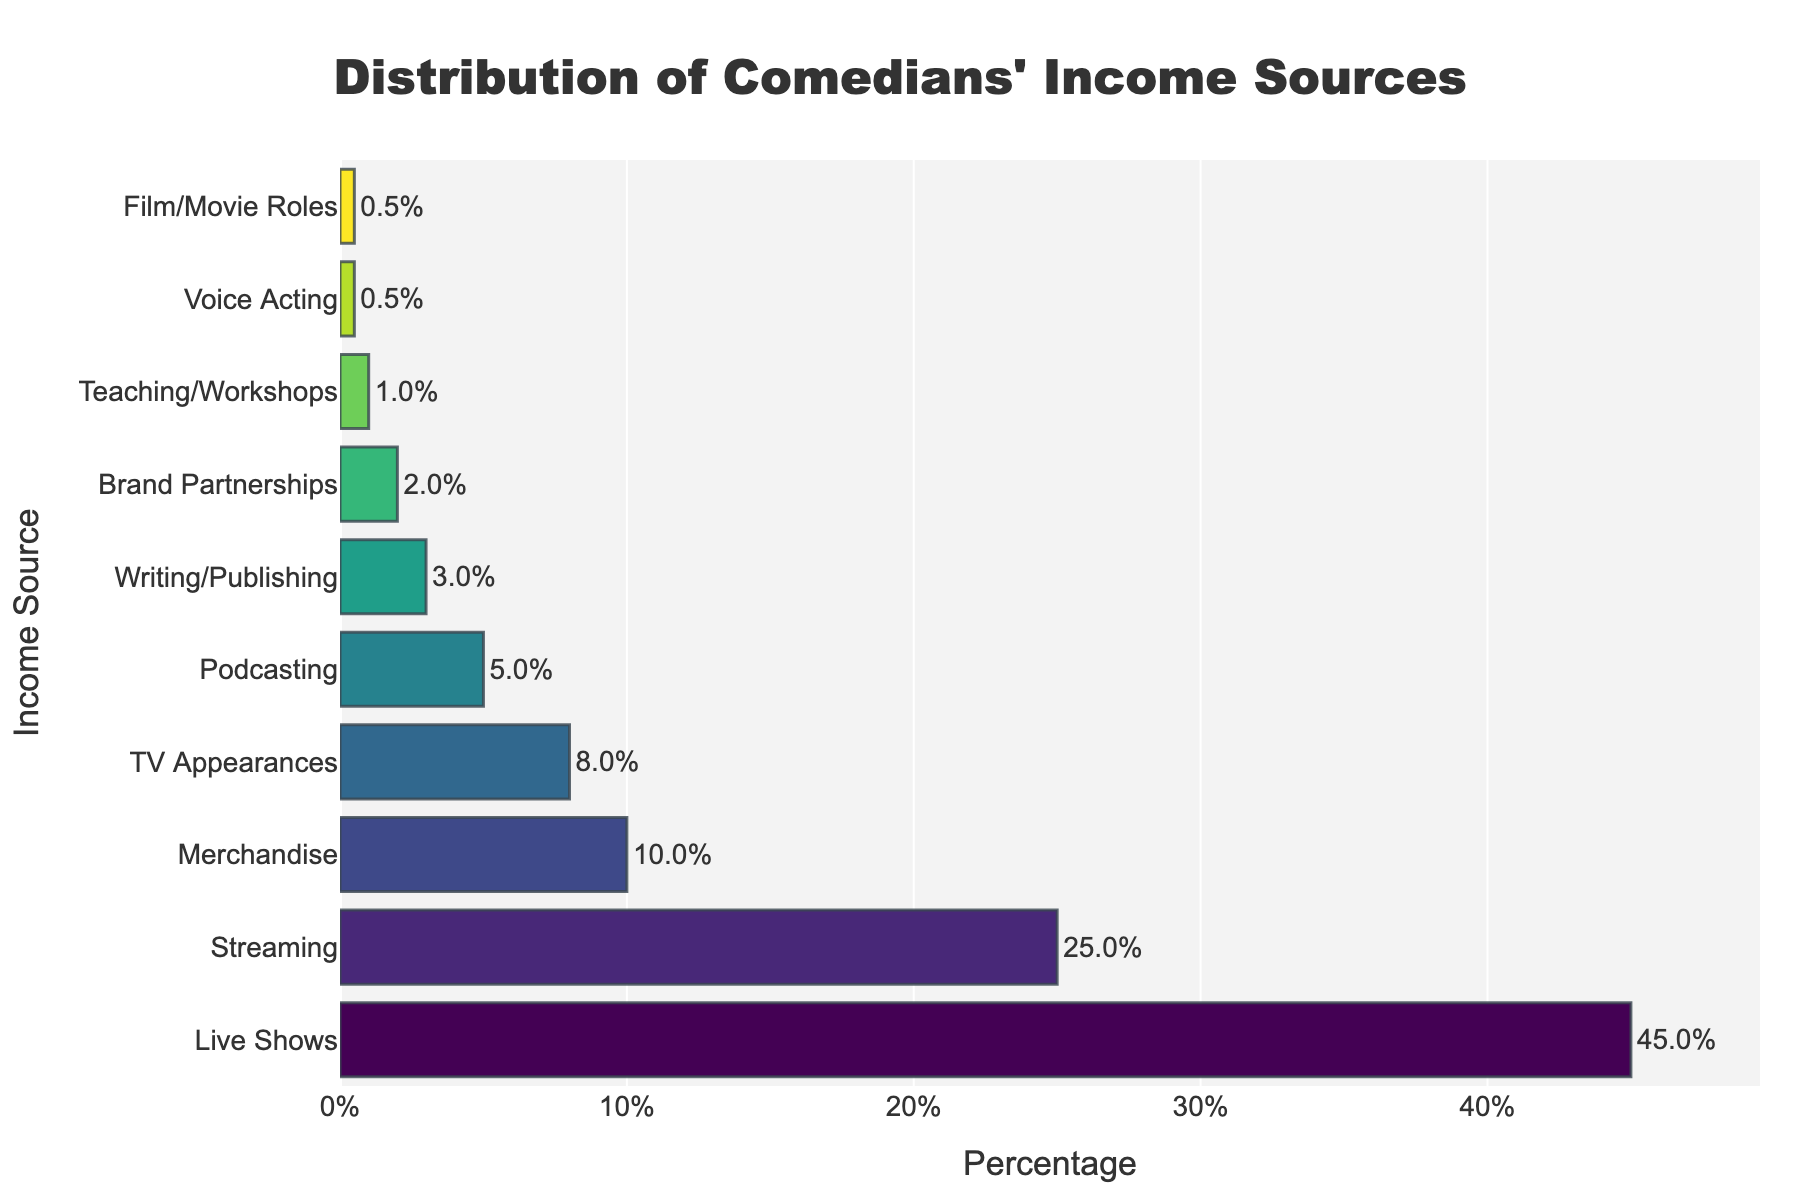Which income source contributes the highest percentage to comedians' income? The bar chart shows the distribution, and the tallest bar represents Live Shows at 45%.
Answer: Live Shows Which two income sources combined equal the percentage contribution of Live Shows? Live Shows is 45%, and combining Streaming (25%) and Merchandise (10%) gives 25% + 10% = 35%, which requires adding another income source. Adding TV Appearances (8%) to the previous sum results in 25% + 10% + 8% = 43%, and including Podcasting (5%) exceeds it. Hence, it’s Streaming (25%) + Merchandise (10%) + TV Appearances (8%) = 43%.
Answer: Streaming, Merchandise, TV Appearances How much higher is the percentage of income from Live Shows compared to Streaming? Live Shows contribute 45%, while Streaming contributes 25%. The difference is 45% - 25% = 20%.
Answer: 20% Which income source has the least contribution, and what is its percentage? The smallest bar represents both Voice Acting and Film/Movie Roles, each with a 0.5% contribution.
Answer: Voice Acting, Film/Movie Roles, 0.5% What percentage of comedians' income comes from activities other than Live Shows, Streaming, and Merchandise? Summing the percentages of the remaining sources: TV Appearances (8%) + Podcasting (5%) + Writing/Publishing (3%) + Brand Partnerships (2%) + Teaching/Workshops (1%) + Voice Acting (0.5%) + Film/Movie Roles (0.5%) = 20%.
Answer: 20% Which is higher: the percentage of income from Podcasting or from Writing/Publishing? The bar for Podcasting is higher at 5%, compared to Writing/Publishing at 3%.
Answer: Podcasting What is the combined percentage income from Brand Partnerships and Teaching/Workshops? Adding their percentages: Brand Partnerships (2%) + Teaching/Workshops (1%) = 3%.
Answer: 3% How many income sources contribute less than 5% each? The bars for TV Appearances, Podcasting, Writing/Publishing, Brand Partnerships, Teaching/Workshops, Voice Acting, and Film/Movie Roles are all below 5%. Counting these gives: 7 sources.
Answer: 7 Is the percentage difference between Teaching/Workshops and Writing/Publishing more than 2%? Teaching/Workshops is at 1%, and Writing/Publishing is at 3%. The difference is 3% - 1% = 2%, which is not more than 2%.
Answer: No What is the average income percentage of the top three sources? The top three sources are Live Shows (45%), Streaming (25%), and Merchandise (10%). Their sum is 45% + 25% + 10% = 80%. The average is 80% / 3 = 26.67%.
Answer: 26.67% 